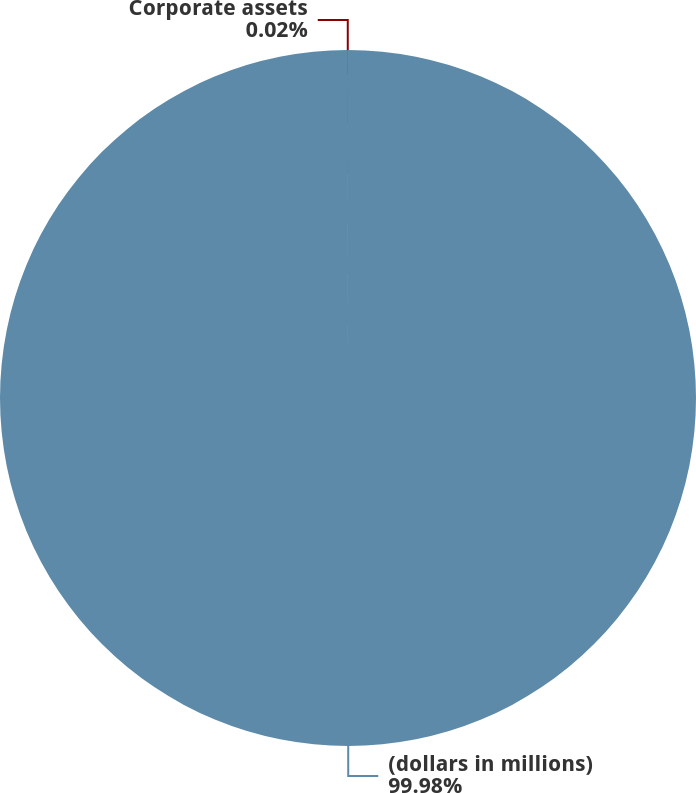Convert chart. <chart><loc_0><loc_0><loc_500><loc_500><pie_chart><fcel>(dollars in millions)<fcel>Corporate assets<nl><fcel>99.98%<fcel>0.02%<nl></chart> 